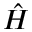<formula> <loc_0><loc_0><loc_500><loc_500>\hat { H }</formula> 